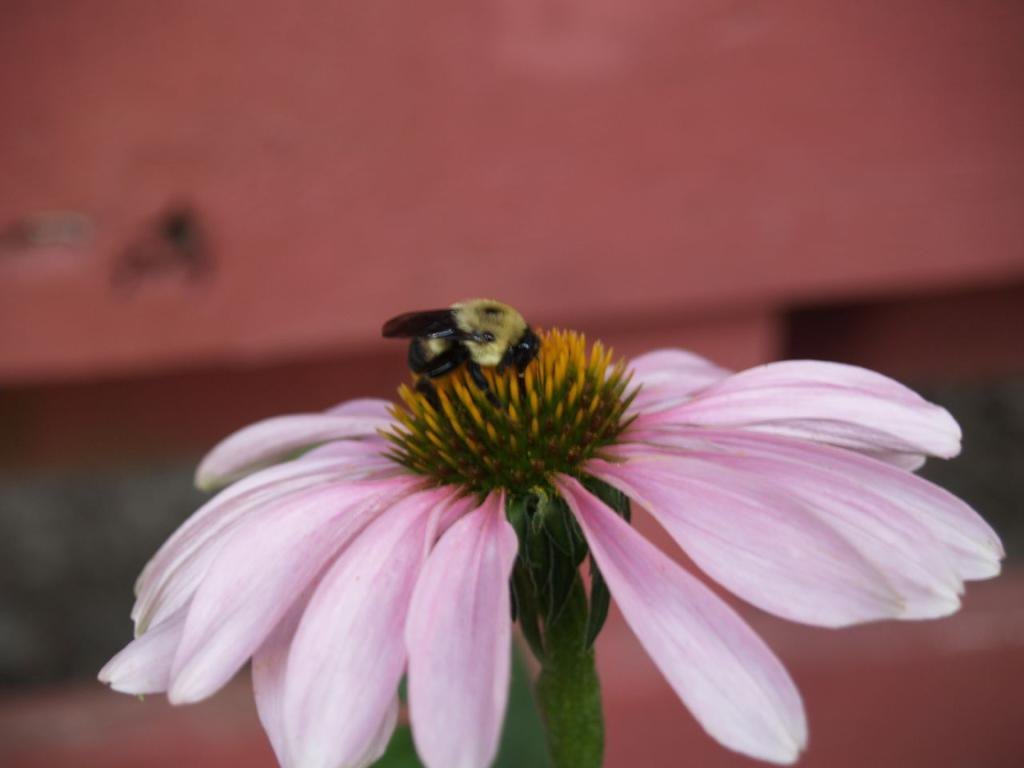What is present in the image? There is a bee in the image. Where is the bee located? The bee is on a flower. What type of grape is the bee pushing in the image? There is no grape present in the image, and the bee is not pushing anything. 